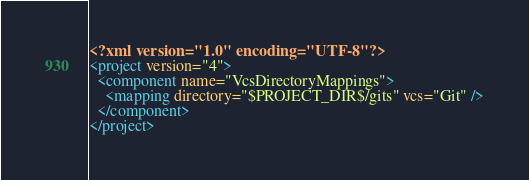Convert code to text. <code><loc_0><loc_0><loc_500><loc_500><_XML_><?xml version="1.0" encoding="UTF-8"?>
<project version="4">
  <component name="VcsDirectoryMappings">
    <mapping directory="$PROJECT_DIR$/gits" vcs="Git" />
  </component>
</project></code> 